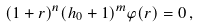<formula> <loc_0><loc_0><loc_500><loc_500>( 1 + r ) ^ { n } ( h _ { 0 } + 1 ) ^ { m } \varphi ( r ) = 0 \, ,</formula> 